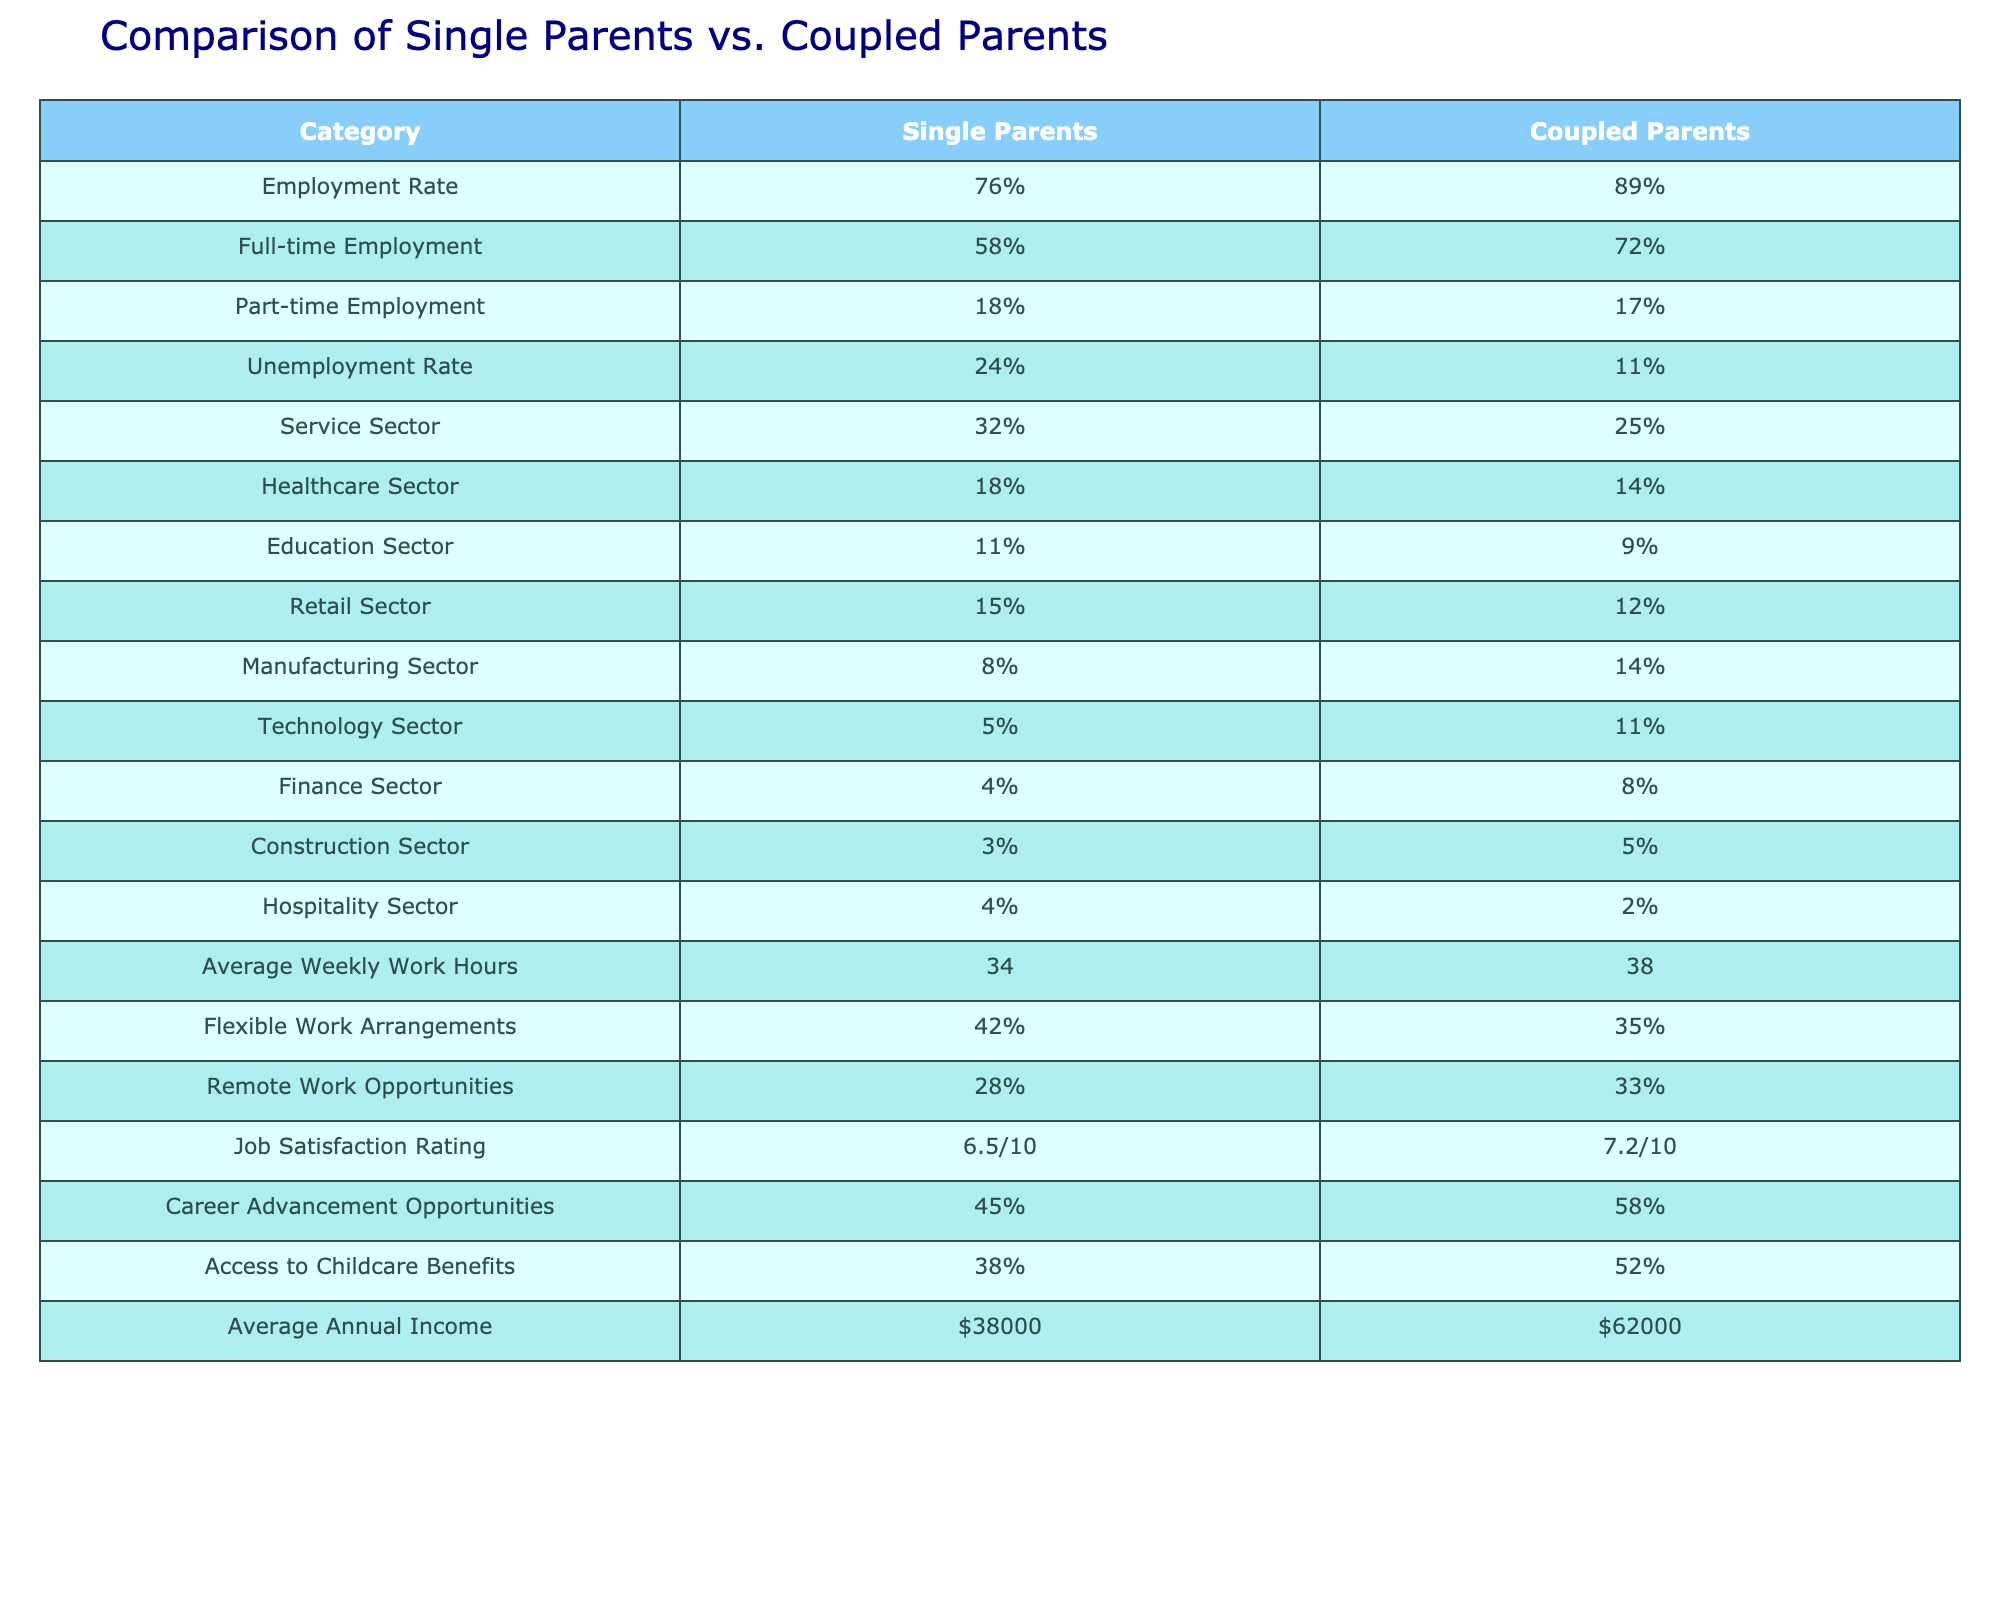What is the employment rate for single parents? The table shows that single parents have an employment rate of 76%.
Answer: 76% What percentage of coupled parents are employed full-time? According to the table, 72% of coupled parents are employed full-time.
Answer: 72% How much higher is the unemployment rate for single parents compared to coupled parents? The unemployment rate for single parents is 24%, while for coupled parents it is 11%. Therefore, the difference is 24% - 11% = 13%.
Answer: 13% What is the average annual income for single parents? The table indicates that single parents have an average annual income of $38,000.
Answer: $38,000 Do single parents have more flexible work arrangements than coupled parents? The table shows that 42% of single parents have flexible work arrangements, whereas 35% of coupled parents do. Therefore, yes, single parents have more flexible work arrangements.
Answer: Yes What sectors show the highest employment for single parents, and which has the least? The table lists the service sector at 32% as the highest employment for single parents and the construction sector at 3% as the least.
Answer: Service sector: 32%, Construction sector: 3% What is the difference in average weekly work hours between single and coupled parents? Single parents work an average of 34 hours weekly, while coupled parents work 38 hours. The difference is 38 - 34 = 4 hours.
Answer: 4 hours What is the job satisfaction rating for coupled parents? The table indicates that coupled parents have a job satisfaction rating of 7.2 out of 10.
Answer: 7.2/10 How do single parents and coupled parents compare in terms of access to childcare benefits? The table shows that 38% of single parents have access to childcare benefits compared to 52% for coupled parents, indicating that coupled parents have better access.
Answer: Coupled parents have better access 